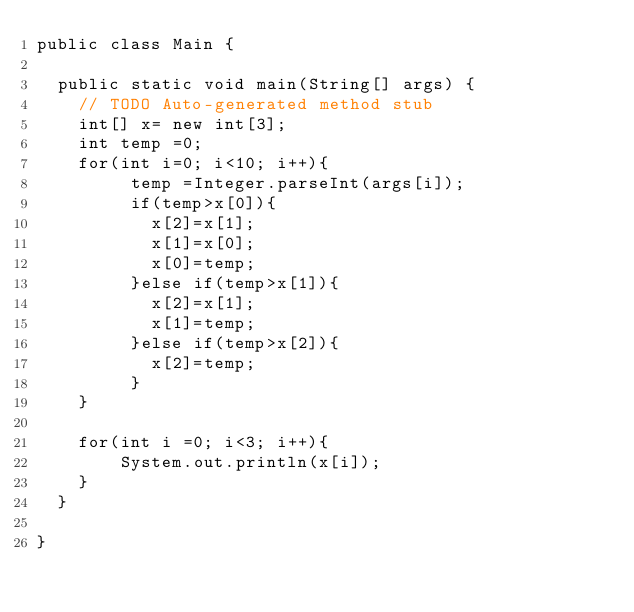Convert code to text. <code><loc_0><loc_0><loc_500><loc_500><_Java_>public class Main {

	public static void main(String[] args) {
		// TODO Auto-generated method stub
		int[] x= new int[3];
		int temp =0;
		for(int i=0; i<10; i++){
		     temp =Integer.parseInt(args[i]);
		     if(temp>x[0]){
		    	 x[2]=x[1];
		    	 x[1]=x[0];
		    	 x[0]=temp;
		     }else if(temp>x[1]){
		    	 x[2]=x[1];
		    	 x[1]=temp;
		     }else if(temp>x[2]){
		    	 x[2]=temp;
		     }
		}
		
		for(int i =0; i<3; i++){
        System.out.println(x[i]);
		}
	}

}</code> 